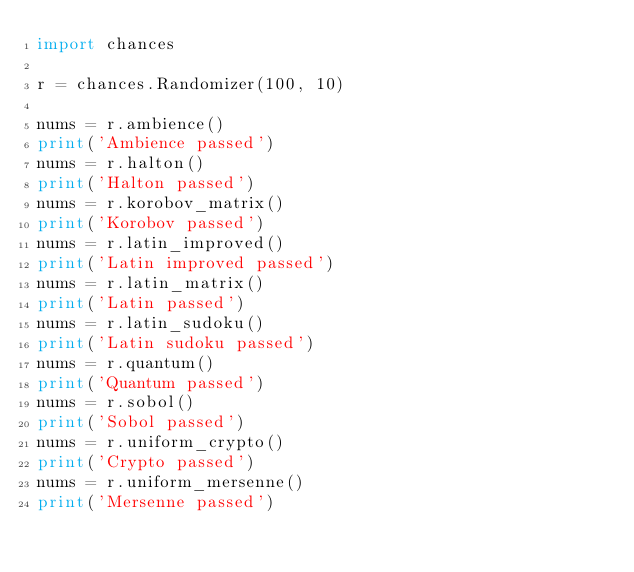<code> <loc_0><loc_0><loc_500><loc_500><_Python_>import chances

r = chances.Randomizer(100, 10)

nums = r.ambience()
print('Ambience passed')
nums = r.halton()
print('Halton passed')
nums = r.korobov_matrix()
print('Korobov passed')
nums = r.latin_improved()
print('Latin improved passed')
nums = r.latin_matrix()
print('Latin passed')
nums = r.latin_sudoku()
print('Latin sudoku passed')
nums = r.quantum()
print('Quantum passed')
nums = r.sobol()
print('Sobol passed')
nums = r.uniform_crypto()
print('Crypto passed')
nums = r.uniform_mersenne()
print('Mersenne passed')
</code> 